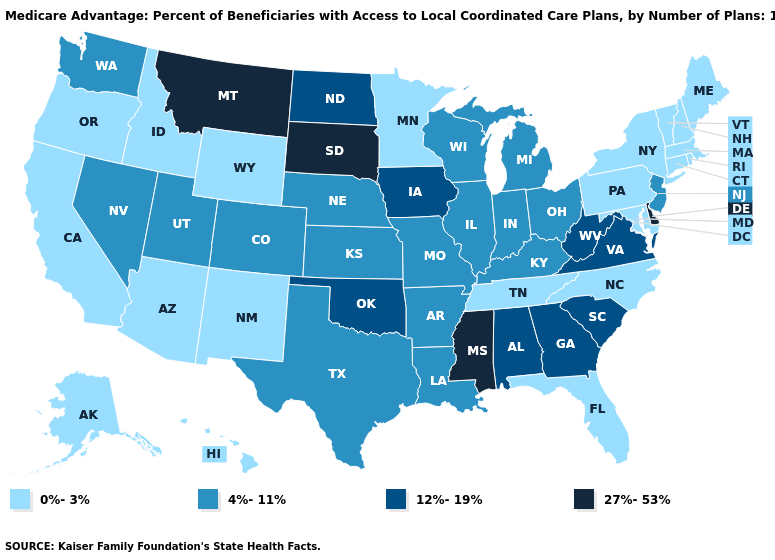Among the states that border South Carolina , which have the highest value?
Be succinct. Georgia. What is the value of Wisconsin?
Short answer required. 4%-11%. Does Indiana have the lowest value in the USA?
Be succinct. No. Among the states that border Alabama , which have the lowest value?
Quick response, please. Florida, Tennessee. What is the value of Indiana?
Write a very short answer. 4%-11%. What is the value of Indiana?
Quick response, please. 4%-11%. What is the highest value in states that border Florida?
Keep it brief. 12%-19%. Which states have the lowest value in the MidWest?
Quick response, please. Minnesota. Does Washington have the lowest value in the West?
Quick response, please. No. Does West Virginia have the highest value in the USA?
Short answer required. No. Does Rhode Island have a higher value than West Virginia?
Answer briefly. No. What is the value of Indiana?
Keep it brief. 4%-11%. Name the states that have a value in the range 0%-3%?
Write a very short answer. Alaska, Arizona, California, Connecticut, Florida, Hawaii, Idaho, Massachusetts, Maryland, Maine, Minnesota, North Carolina, New Hampshire, New Mexico, New York, Oregon, Pennsylvania, Rhode Island, Tennessee, Vermont, Wyoming. What is the lowest value in the USA?
Concise answer only. 0%-3%. What is the value of Nebraska?
Short answer required. 4%-11%. 